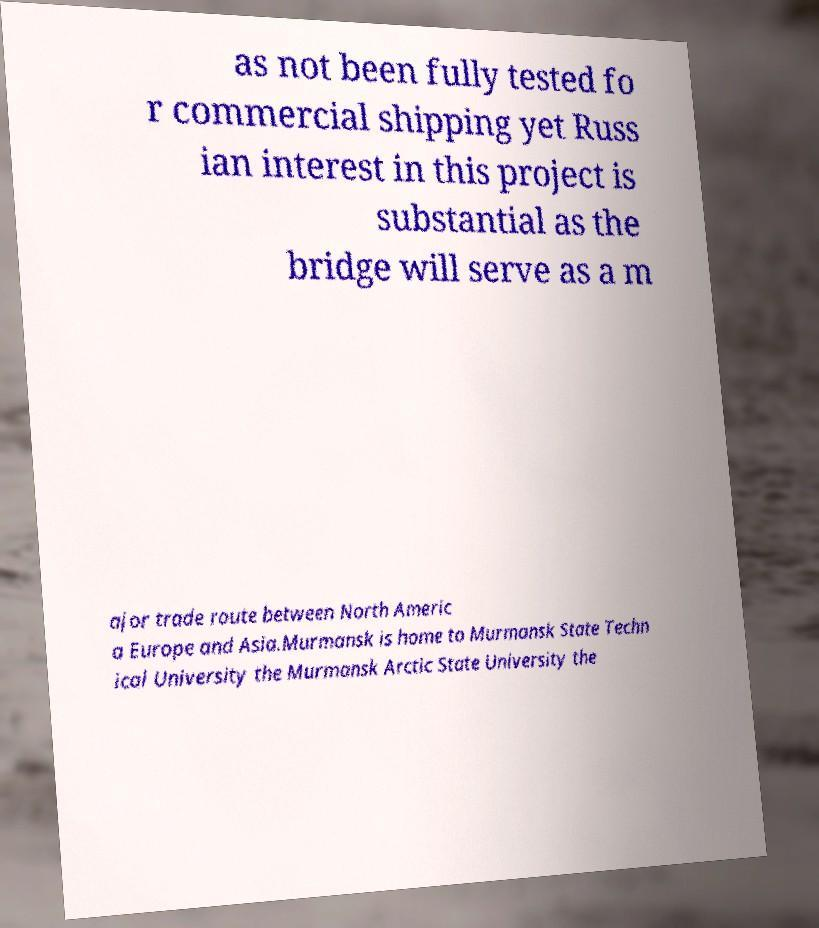Can you accurately transcribe the text from the provided image for me? as not been fully tested fo r commercial shipping yet Russ ian interest in this project is substantial as the bridge will serve as a m ajor trade route between North Americ a Europe and Asia.Murmansk is home to Murmansk State Techn ical University the Murmansk Arctic State University the 